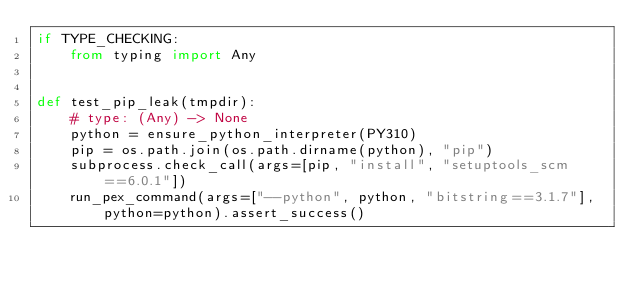Convert code to text. <code><loc_0><loc_0><loc_500><loc_500><_Python_>if TYPE_CHECKING:
    from typing import Any


def test_pip_leak(tmpdir):
    # type: (Any) -> None
    python = ensure_python_interpreter(PY310)
    pip = os.path.join(os.path.dirname(python), "pip")
    subprocess.check_call(args=[pip, "install", "setuptools_scm==6.0.1"])
    run_pex_command(args=["--python", python, "bitstring==3.1.7"], python=python).assert_success()
</code> 